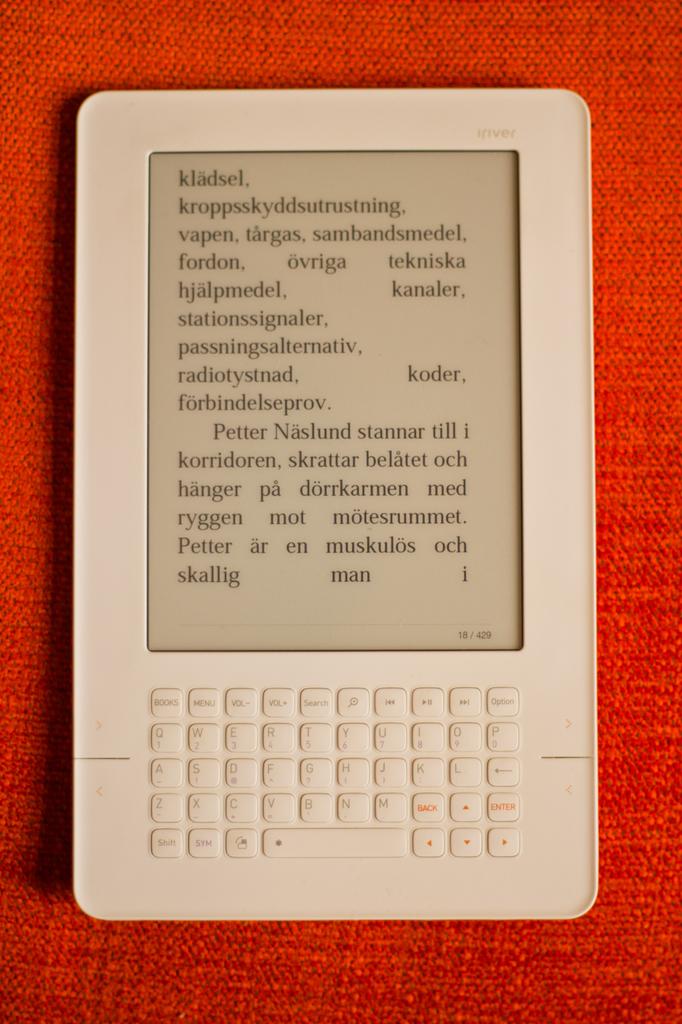What is the last word?
Make the answer very short. I. 